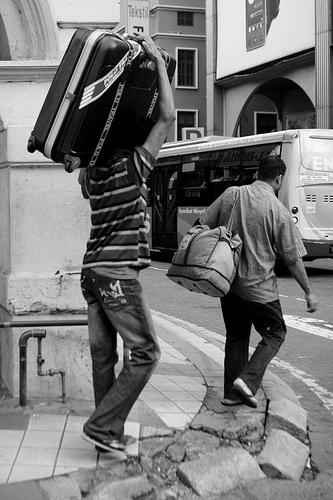Question: what is the man holding on his shoulder?
Choices:
A. Child.
B. Box.
C. A suitcase.
D. Cord.
Answer with the letter. Answer: C Question: how many men are there?
Choices:
A. Three.
B. Two.
C. Four.
D. Five.
Answer with the letter. Answer: B Question: what design is on the man's shirt in the back?
Choices:
A. Plaid.
B. Paisley.
C. Solid.
D. Stripes.
Answer with the letter. Answer: D Question: what type of vehicle is in the background?
Choices:
A. Car.
B. Bus.
C. Motorcycle.
D. Boat.
Answer with the letter. Answer: B Question: what color is this picture?
Choices:
A. Black and white.
B. Gray.
C. Red.
D. Blue.
Answer with the letter. Answer: A Question: where is there broken stone?
Choices:
A. Sidewalk.
B. Side of house.
C. In cementary.
D. On statue.
Answer with the letter. Answer: A Question: where is the man in back holding the suitcase?
Choices:
A. His shoulder.
B. In hand.
C. On back.
D. On cart.
Answer with the letter. Answer: A 